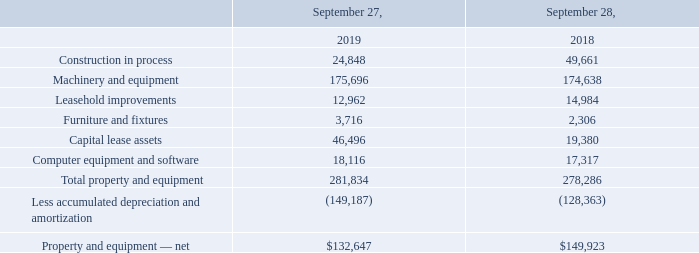9. PROPERTY, PLANT AND EQUIPMENT
Property, plant and equipment consists of the following (in thousands):
Depreciation and amortization expense related to property and equipment for fiscal years 2019, 2018 and 2017 was $29.7 million, $30.7 million and $27.3 million, respectively. Accumulated depreciation on capital lease assets for fiscal years 2019 and 2018 was $5.3 million and $3.2 million, respectively.
See Note 17 - Impairments and Note 15 - Restructurings for information related to property and equipment impaired during fiscal year 2019.
What was the depreciation and amortization expense related to property and equipment for 2019? $29.7 million. What was the respective value of construction in process in 2019 and 2018?
Answer scale should be: thousand. 24,848, 49,661. What was the value of Machinery and equipment in 2019?
Answer scale should be: thousand. 175,696. In which year was value of Construction in process less than 30,000 thousands? Locate and analyze construction in process in row 3
answer: 2019. What was the average value of Machinery and equipment for 2018 and 2019?
Answer scale should be: thousand. (175,696 + 174,638) / 2
Answer: 175167. What is the change in the Leasehold improvements from 2018 to 2019?
Answer scale should be: thousand. 12,962 - 14,984
Answer: -2022. 